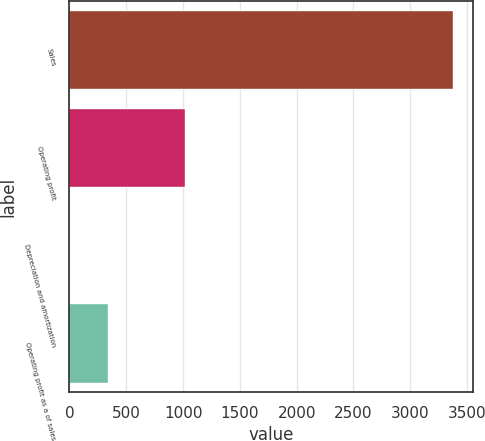Convert chart. <chart><loc_0><loc_0><loc_500><loc_500><bar_chart><fcel>Sales<fcel>Operating profit<fcel>Depreciation and amortization<fcel>Operating profit as a of sales<nl><fcel>3381<fcel>1017.03<fcel>3.9<fcel>341.61<nl></chart> 